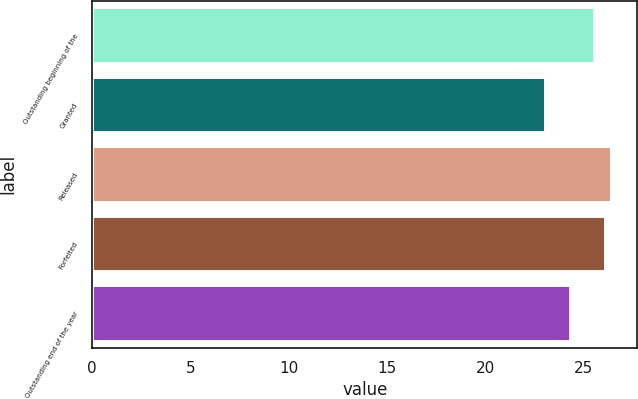Convert chart to OTSL. <chart><loc_0><loc_0><loc_500><loc_500><bar_chart><fcel>Outstanding beginning of the<fcel>Granted<fcel>Released<fcel>Forfeited<fcel>Outstanding end of the year<nl><fcel>25.54<fcel>23.07<fcel>26.43<fcel>26.1<fcel>24.34<nl></chart> 